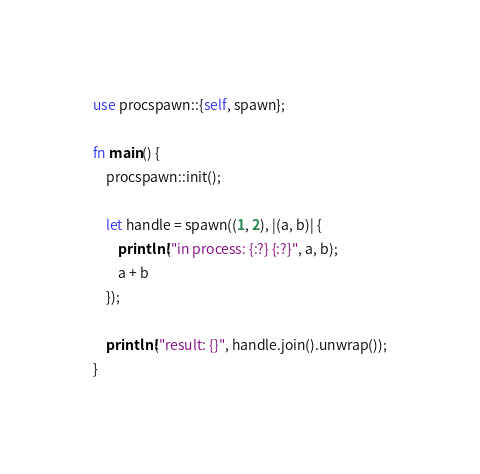Convert code to text. <code><loc_0><loc_0><loc_500><loc_500><_Rust_>use procspawn::{self, spawn};

fn main() {
    procspawn::init();

    let handle = spawn((1, 2), |(a, b)| {
        println!("in process: {:?} {:?}", a, b);
        a + b
    });

    println!("result: {}", handle.join().unwrap());
}
</code> 